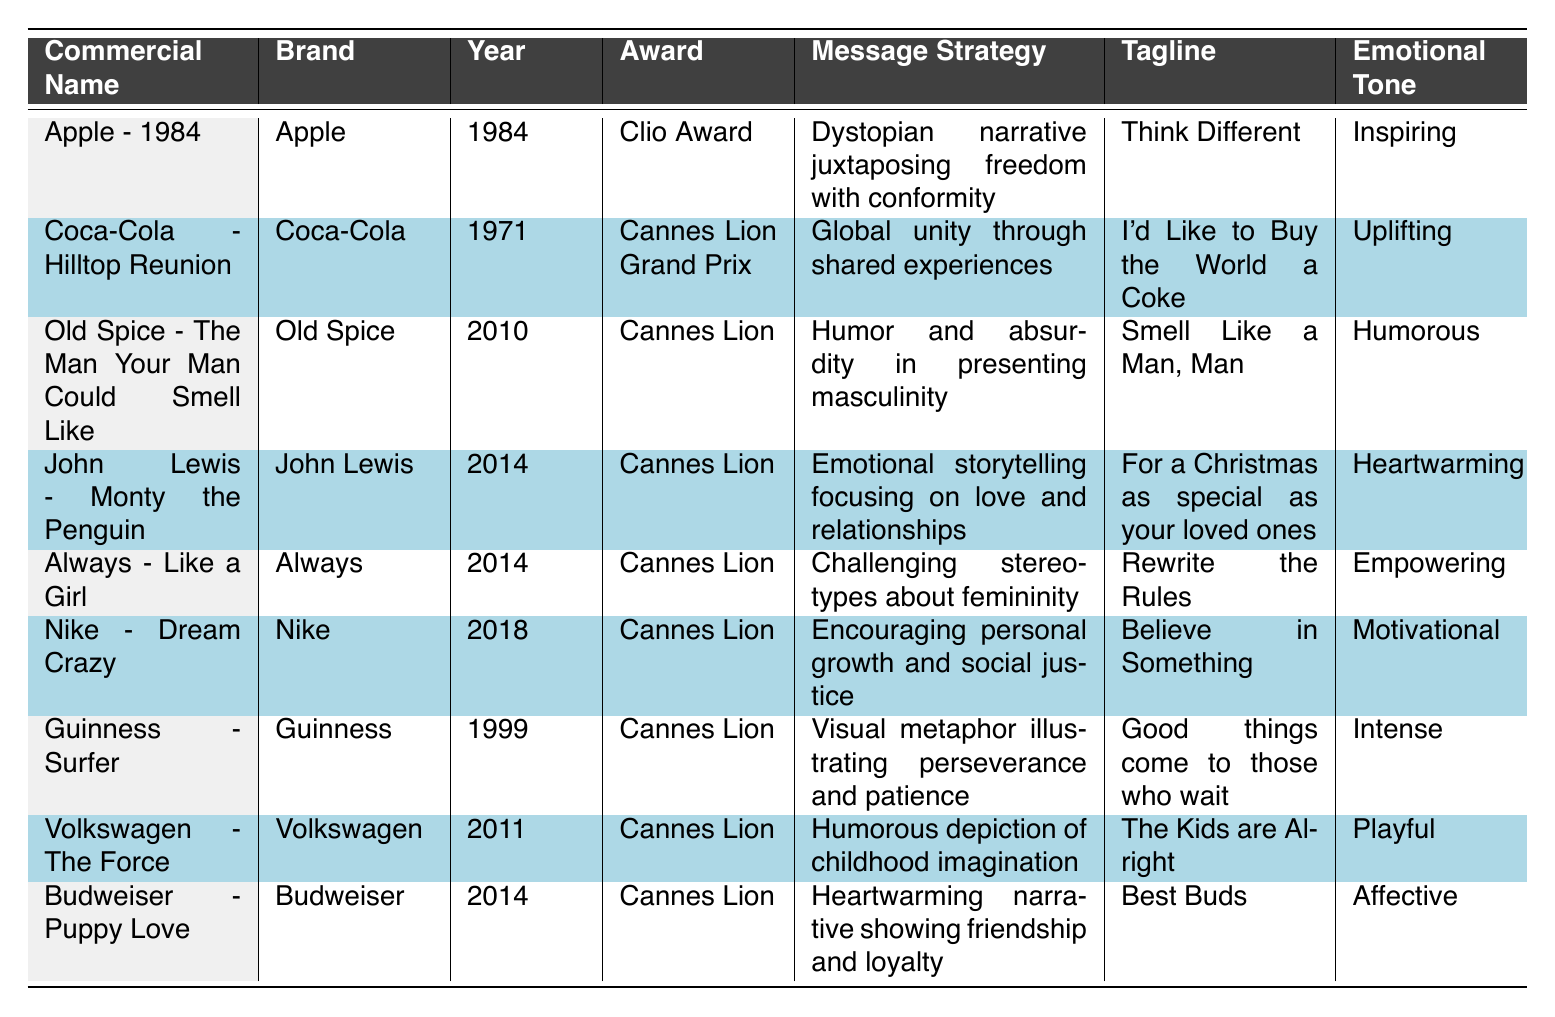What is the emotional tone of the "Always - Like a Girl" commercial? The emotional tone for this commercial is listed in the table under the corresponding row, which states "Empowering."
Answer: Empowering Which commercial won the Cannes Lion Grand Prix? By checking the award column for the highest distinction, "Cannes Lion Grand Prix" is associated with the "Coca-Cola - Hilltop Reunion" commercial from 1971.
Answer: Coca-Cola - Hilltop Reunion How many commercials rely on humor as a message strategy? Counting the rows in the table, "Old Spice - The Man Your Man Could Smell Like," and "Volkswagen - The Force" both utilize humor in their message strategies, totaling two commercials.
Answer: 2 Did any commercial from the year 2014 win an award? Looking at the table, the commercials "John Lewis - Monty the Penguin," "Always - Like a Girl," and "Budweiser - Puppy Love" were all awarded in 2014, confirming that there were indeed commercials from that year that won awards.
Answer: Yes Based on the table, which brand has the earliest commercial, and what is its tagline? The earliest commercial listed is from "Apple" in 1984, which has the tagline "Think Different." This is evident when filtering through the year column and checking the related tagline.
Answer: Apple, Think Different What is the difference in the years of the "Nike - Dream Crazy" and "Guinness - Surfer" commercials? The "Nike - Dream Crazy" commercial was released in 2018, and "Guinness - Surfer" in 1999. The difference between these two years is calculated as 2018 - 1999 = 19 years.
Answer: 19 years How many commercials have an emotional tone described as heartwarming? In the table, only one commercial, "John Lewis - Monty the Penguin," is categorized with the emotional tone "Heartwarming," indicating that there is one such commercial.
Answer: 1 What is the message strategy of the "Nike - Dream Crazy" commercial? Looking at the message strategy column for the "Nike - Dream Crazy" commercial reveals it employs a strategy that encourages personal growth and social justice, which is explicitly stated in the table.
Answer: Encouraging personal growth and social justice Which commercial uses a dystopian narrative as part of its messaging strategy? In the table, the "Apple - 1984" commercial's message strategy indicates it employs a dystopian narrative to discuss themes of freedom and conformity, making it the only one of its kind in the table.
Answer: Apple - 1984 